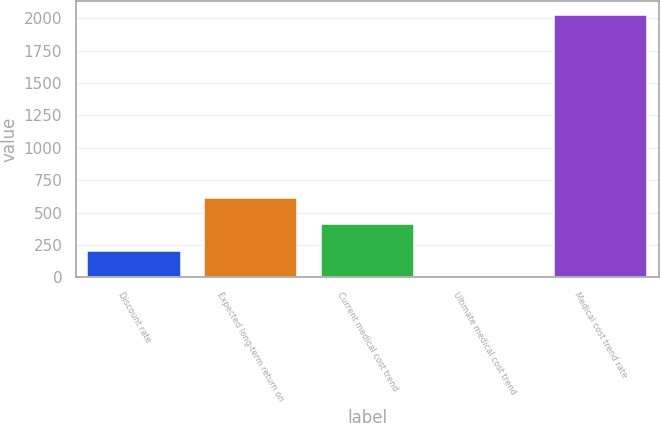Convert chart to OTSL. <chart><loc_0><loc_0><loc_500><loc_500><bar_chart><fcel>Discount rate<fcel>Expected long-term return on<fcel>Current medical cost trend<fcel>Ultimate medical cost trend<fcel>Medical cost trend rate<nl><fcel>206.05<fcel>611.15<fcel>408.6<fcel>3.5<fcel>2029<nl></chart> 